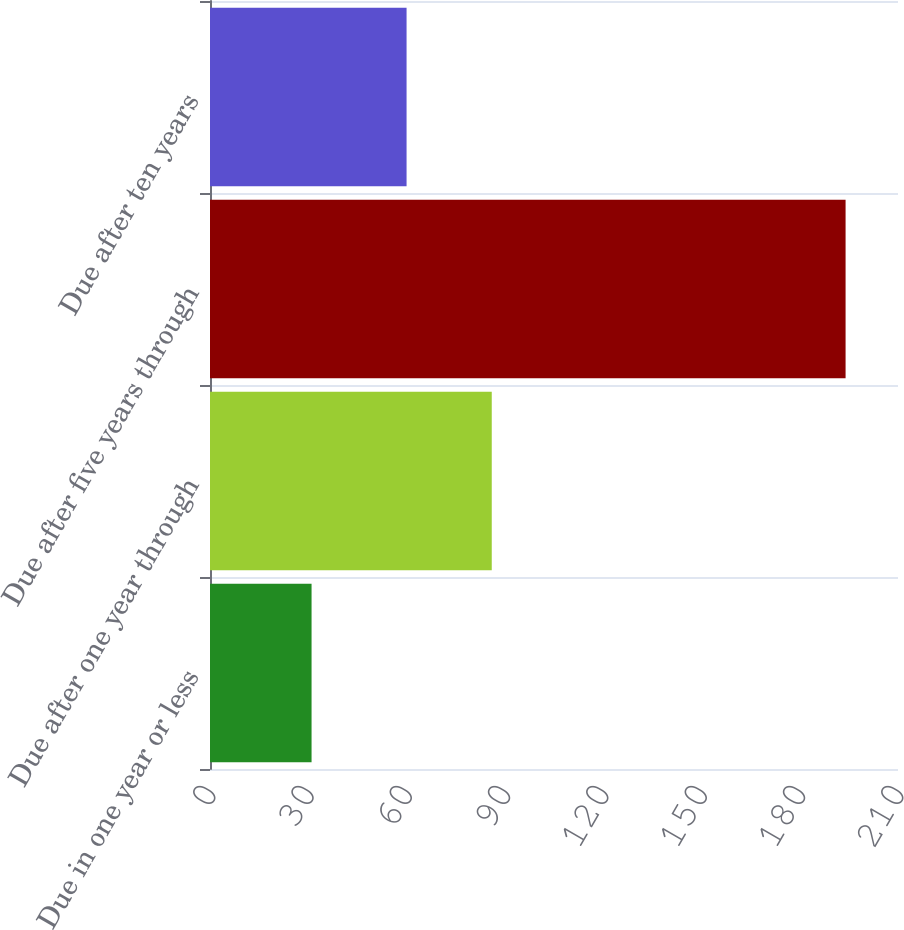Convert chart to OTSL. <chart><loc_0><loc_0><loc_500><loc_500><bar_chart><fcel>Due in one year or less<fcel>Due after one year through<fcel>Due after five years through<fcel>Due after ten years<nl><fcel>31<fcel>86<fcel>194<fcel>60<nl></chart> 